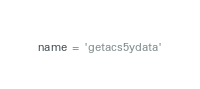<code> <loc_0><loc_0><loc_500><loc_500><_Python_>name = 'getacs5ydata'</code> 